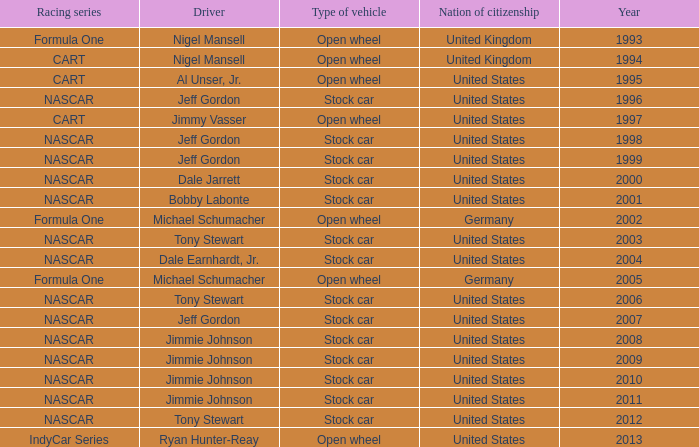What year has the vehicle of open wheel and a racing series of formula one with a Nation of citizenship in Germany. 2002, 2005. 